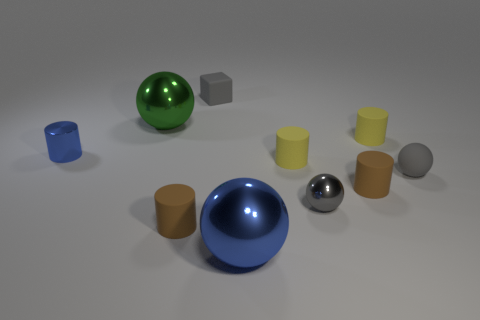Subtract all small gray shiny spheres. How many spheres are left? 3 Subtract all green balls. How many balls are left? 3 Subtract 3 cylinders. How many cylinders are left? 2 Subtract all blocks. How many objects are left? 9 Subtract all brown cylinders. Subtract all brown cubes. How many cylinders are left? 3 Subtract all blue blocks. How many purple cylinders are left? 0 Subtract all tiny metallic things. Subtract all big metal objects. How many objects are left? 6 Add 8 blue things. How many blue things are left? 10 Add 1 large blue objects. How many large blue objects exist? 2 Subtract 1 gray blocks. How many objects are left? 9 